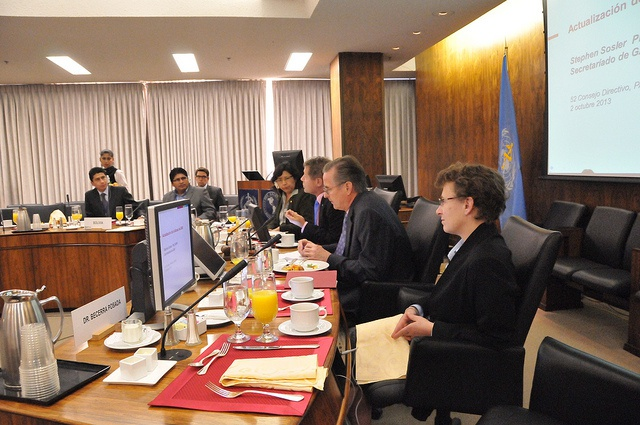Describe the objects in this image and their specific colors. I can see tv in lightgray, black, and darkgray tones, people in lightgray, black, brown, tan, and maroon tones, chair in lightgray, black, and gray tones, people in lightgray, black, gray, brown, and salmon tones, and chair in lightgray, black, and gray tones in this image. 